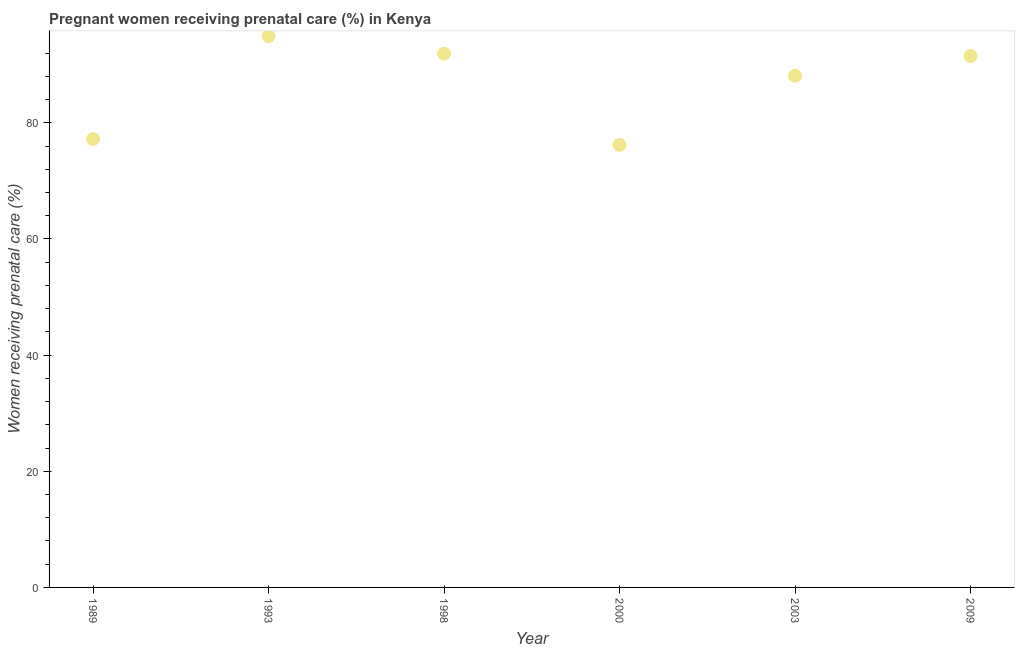What is the percentage of pregnant women receiving prenatal care in 2000?
Give a very brief answer. 76.2. Across all years, what is the maximum percentage of pregnant women receiving prenatal care?
Your answer should be very brief. 94.9. Across all years, what is the minimum percentage of pregnant women receiving prenatal care?
Provide a short and direct response. 76.2. In which year was the percentage of pregnant women receiving prenatal care maximum?
Offer a very short reply. 1993. What is the sum of the percentage of pregnant women receiving prenatal care?
Offer a terse response. 519.8. What is the difference between the percentage of pregnant women receiving prenatal care in 1998 and 2003?
Your answer should be very brief. 3.8. What is the average percentage of pregnant women receiving prenatal care per year?
Your answer should be compact. 86.63. What is the median percentage of pregnant women receiving prenatal care?
Your response must be concise. 89.8. In how many years, is the percentage of pregnant women receiving prenatal care greater than 12 %?
Your answer should be compact. 6. Do a majority of the years between 1993 and 1998 (inclusive) have percentage of pregnant women receiving prenatal care greater than 64 %?
Your answer should be very brief. Yes. What is the ratio of the percentage of pregnant women receiving prenatal care in 2003 to that in 2009?
Provide a short and direct response. 0.96. Is the percentage of pregnant women receiving prenatal care in 1993 less than that in 2000?
Your answer should be compact. No. Is the difference between the percentage of pregnant women receiving prenatal care in 1993 and 2003 greater than the difference between any two years?
Ensure brevity in your answer.  No. What is the difference between the highest and the lowest percentage of pregnant women receiving prenatal care?
Your response must be concise. 18.7. In how many years, is the percentage of pregnant women receiving prenatal care greater than the average percentage of pregnant women receiving prenatal care taken over all years?
Provide a short and direct response. 4. Does the percentage of pregnant women receiving prenatal care monotonically increase over the years?
Offer a terse response. No. How many dotlines are there?
Keep it short and to the point. 1. What is the title of the graph?
Offer a very short reply. Pregnant women receiving prenatal care (%) in Kenya. What is the label or title of the Y-axis?
Your answer should be very brief. Women receiving prenatal care (%). What is the Women receiving prenatal care (%) in 1989?
Your answer should be very brief. 77.2. What is the Women receiving prenatal care (%) in 1993?
Give a very brief answer. 94.9. What is the Women receiving prenatal care (%) in 1998?
Make the answer very short. 91.9. What is the Women receiving prenatal care (%) in 2000?
Provide a succinct answer. 76.2. What is the Women receiving prenatal care (%) in 2003?
Offer a terse response. 88.1. What is the Women receiving prenatal care (%) in 2009?
Provide a short and direct response. 91.5. What is the difference between the Women receiving prenatal care (%) in 1989 and 1993?
Keep it short and to the point. -17.7. What is the difference between the Women receiving prenatal care (%) in 1989 and 1998?
Your response must be concise. -14.7. What is the difference between the Women receiving prenatal care (%) in 1989 and 2009?
Offer a terse response. -14.3. What is the difference between the Women receiving prenatal care (%) in 1993 and 1998?
Your answer should be compact. 3. What is the difference between the Women receiving prenatal care (%) in 1998 and 2000?
Keep it short and to the point. 15.7. What is the difference between the Women receiving prenatal care (%) in 1998 and 2003?
Provide a succinct answer. 3.8. What is the difference between the Women receiving prenatal care (%) in 2000 and 2003?
Ensure brevity in your answer.  -11.9. What is the difference between the Women receiving prenatal care (%) in 2000 and 2009?
Make the answer very short. -15.3. What is the ratio of the Women receiving prenatal care (%) in 1989 to that in 1993?
Offer a terse response. 0.81. What is the ratio of the Women receiving prenatal care (%) in 1989 to that in 1998?
Make the answer very short. 0.84. What is the ratio of the Women receiving prenatal care (%) in 1989 to that in 2000?
Offer a very short reply. 1.01. What is the ratio of the Women receiving prenatal care (%) in 1989 to that in 2003?
Make the answer very short. 0.88. What is the ratio of the Women receiving prenatal care (%) in 1989 to that in 2009?
Give a very brief answer. 0.84. What is the ratio of the Women receiving prenatal care (%) in 1993 to that in 1998?
Your answer should be very brief. 1.03. What is the ratio of the Women receiving prenatal care (%) in 1993 to that in 2000?
Keep it short and to the point. 1.25. What is the ratio of the Women receiving prenatal care (%) in 1993 to that in 2003?
Your answer should be very brief. 1.08. What is the ratio of the Women receiving prenatal care (%) in 1998 to that in 2000?
Provide a short and direct response. 1.21. What is the ratio of the Women receiving prenatal care (%) in 1998 to that in 2003?
Make the answer very short. 1.04. What is the ratio of the Women receiving prenatal care (%) in 2000 to that in 2003?
Ensure brevity in your answer.  0.86. What is the ratio of the Women receiving prenatal care (%) in 2000 to that in 2009?
Your answer should be very brief. 0.83. 